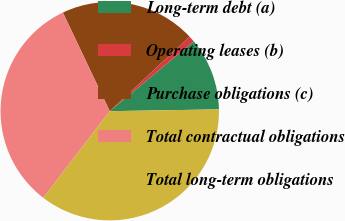Convert chart to OTSL. <chart><loc_0><loc_0><loc_500><loc_500><pie_chart><fcel>Long-term debt (a)<fcel>Operating leases (b)<fcel>Purchase obligations (c)<fcel>Total contractual obligations<fcel>Total long-term obligations<nl><fcel>10.77%<fcel>0.93%<fcel>20.1%<fcel>32.52%<fcel>35.68%<nl></chart> 